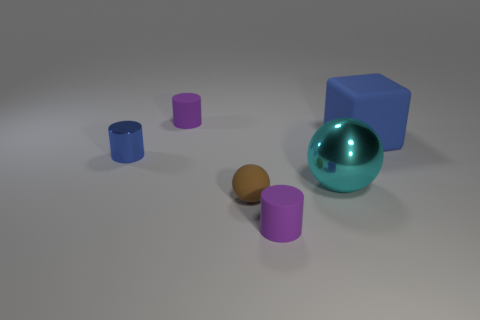How many objects are there and what are their colors? There are six objects in total: one teal sphere, one blue cube, two purple cylinders of different sizes, and two brown spheres, also of different sizes. 